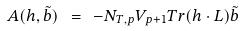Convert formula to latex. <formula><loc_0><loc_0><loc_500><loc_500>A ( h , \tilde { b } ) \ = \ - N _ { T , p } V _ { p + 1 } T r ( h \cdot L ) \tilde { b }</formula> 